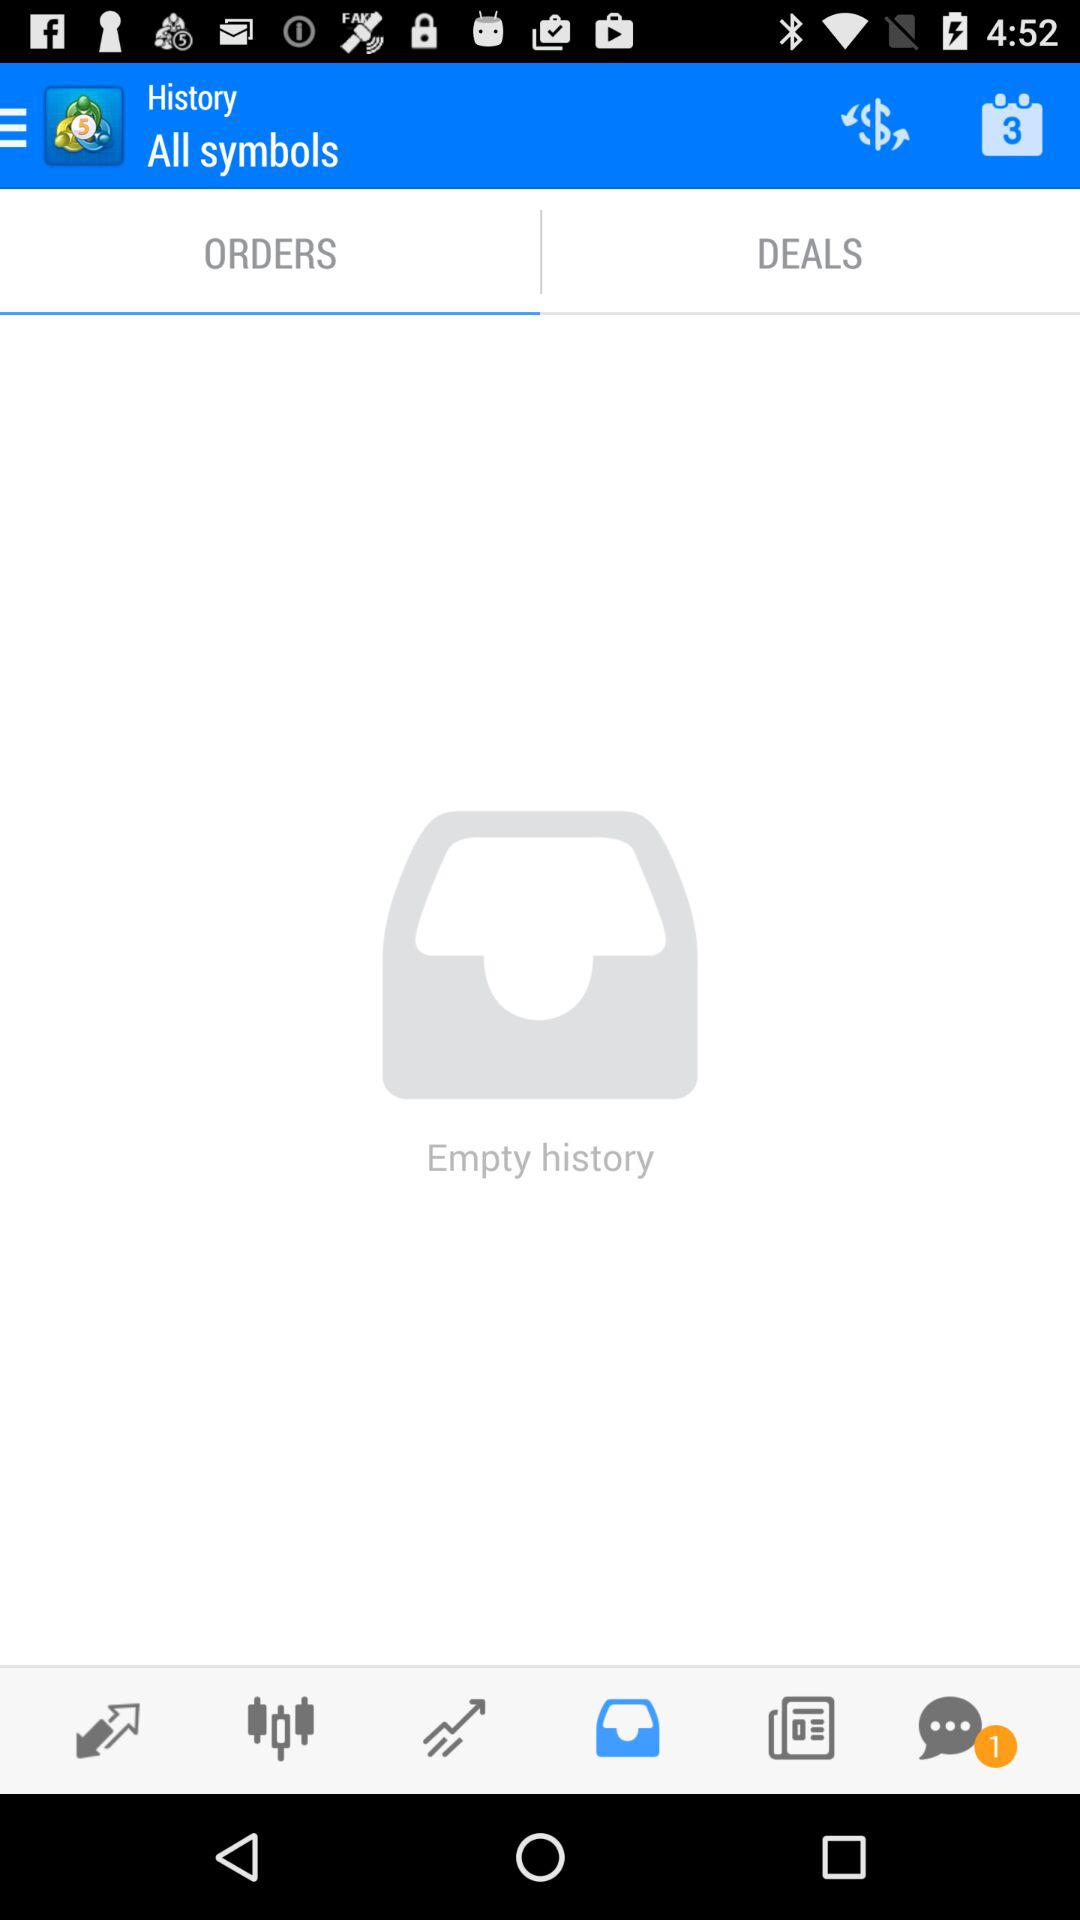How many unread notifications are there in the chat box? There is 1 notification in the chat box. 